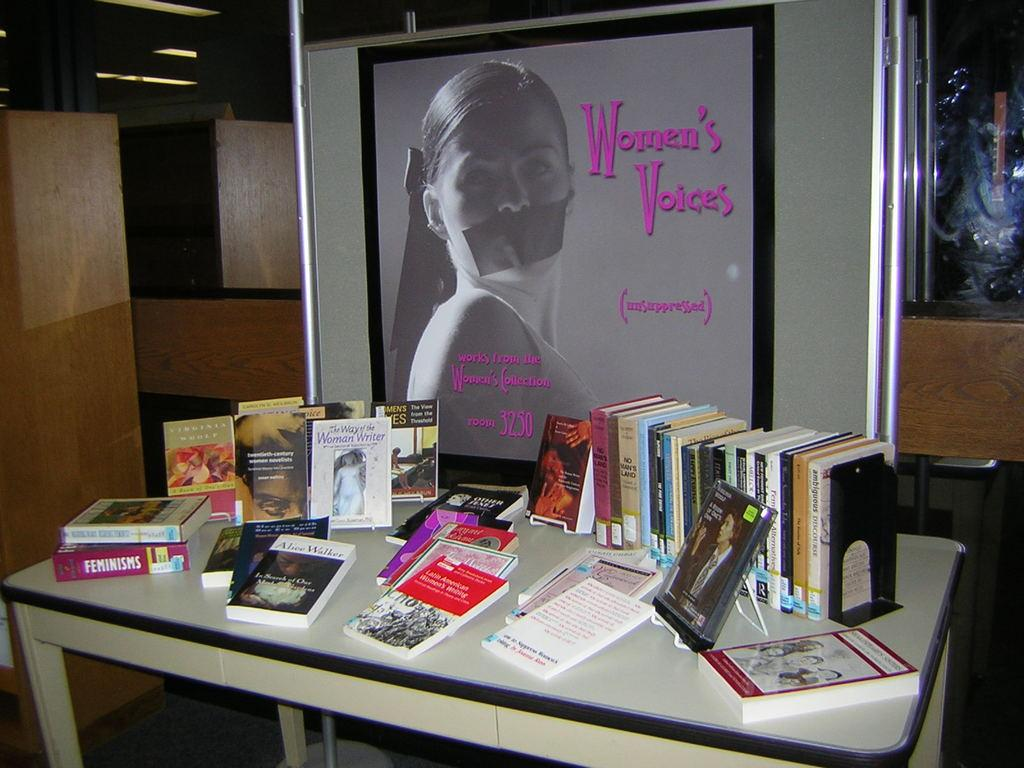<image>
Relay a brief, clear account of the picture shown. A white desk filled with book piles and a picture frame that reads Women's  Voices. 